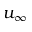Convert formula to latex. <formula><loc_0><loc_0><loc_500><loc_500>u _ { \infty }</formula> 